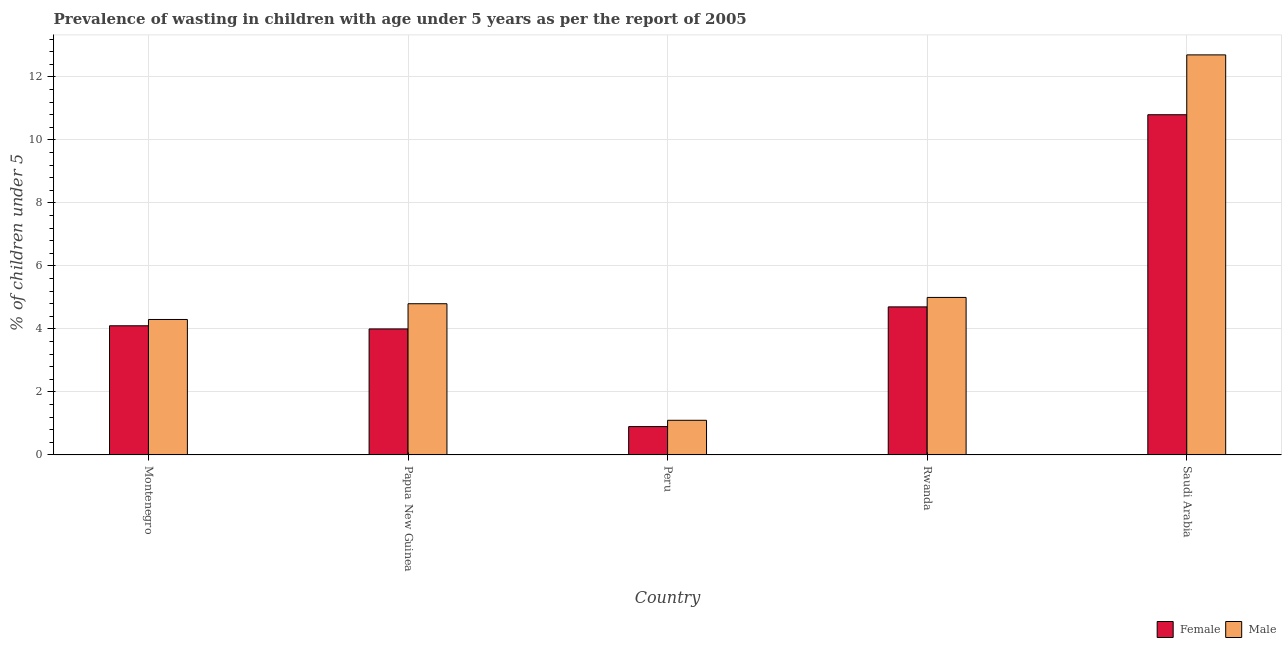How many different coloured bars are there?
Your answer should be compact. 2. How many groups of bars are there?
Make the answer very short. 5. What is the label of the 4th group of bars from the left?
Your answer should be compact. Rwanda. What is the percentage of undernourished female children in Montenegro?
Give a very brief answer. 4.1. Across all countries, what is the maximum percentage of undernourished male children?
Provide a succinct answer. 12.7. Across all countries, what is the minimum percentage of undernourished female children?
Provide a short and direct response. 0.9. In which country was the percentage of undernourished male children maximum?
Your answer should be compact. Saudi Arabia. What is the total percentage of undernourished male children in the graph?
Your answer should be very brief. 27.9. What is the difference between the percentage of undernourished male children in Rwanda and that in Saudi Arabia?
Keep it short and to the point. -7.7. What is the difference between the percentage of undernourished female children in Montenegro and the percentage of undernourished male children in Papua New Guinea?
Give a very brief answer. -0.7. What is the average percentage of undernourished female children per country?
Provide a short and direct response. 4.9. What is the difference between the percentage of undernourished female children and percentage of undernourished male children in Papua New Guinea?
Keep it short and to the point. -0.8. In how many countries, is the percentage of undernourished female children greater than 12.8 %?
Provide a succinct answer. 0. What is the ratio of the percentage of undernourished female children in Papua New Guinea to that in Peru?
Ensure brevity in your answer.  4.44. Is the difference between the percentage of undernourished male children in Montenegro and Saudi Arabia greater than the difference between the percentage of undernourished female children in Montenegro and Saudi Arabia?
Provide a short and direct response. No. What is the difference between the highest and the second highest percentage of undernourished female children?
Ensure brevity in your answer.  6.1. What is the difference between the highest and the lowest percentage of undernourished female children?
Ensure brevity in your answer.  9.9. Is the sum of the percentage of undernourished male children in Peru and Saudi Arabia greater than the maximum percentage of undernourished female children across all countries?
Ensure brevity in your answer.  Yes. What does the 2nd bar from the right in Rwanda represents?
Your answer should be compact. Female. Are all the bars in the graph horizontal?
Provide a succinct answer. No. How many countries are there in the graph?
Provide a short and direct response. 5. Does the graph contain any zero values?
Provide a succinct answer. No. Does the graph contain grids?
Give a very brief answer. Yes. Where does the legend appear in the graph?
Give a very brief answer. Bottom right. How many legend labels are there?
Your answer should be compact. 2. What is the title of the graph?
Your answer should be very brief. Prevalence of wasting in children with age under 5 years as per the report of 2005. Does "By country of asylum" appear as one of the legend labels in the graph?
Your response must be concise. No. What is the label or title of the Y-axis?
Make the answer very short.  % of children under 5. What is the  % of children under 5 in Female in Montenegro?
Keep it short and to the point. 4.1. What is the  % of children under 5 in Male in Montenegro?
Provide a succinct answer. 4.3. What is the  % of children under 5 in Male in Papua New Guinea?
Make the answer very short. 4.8. What is the  % of children under 5 of Female in Peru?
Offer a terse response. 0.9. What is the  % of children under 5 of Male in Peru?
Offer a very short reply. 1.1. What is the  % of children under 5 of Female in Rwanda?
Your response must be concise. 4.7. What is the  % of children under 5 of Female in Saudi Arabia?
Make the answer very short. 10.8. What is the  % of children under 5 of Male in Saudi Arabia?
Your answer should be compact. 12.7. Across all countries, what is the maximum  % of children under 5 in Female?
Offer a terse response. 10.8. Across all countries, what is the maximum  % of children under 5 in Male?
Your answer should be very brief. 12.7. Across all countries, what is the minimum  % of children under 5 of Female?
Your response must be concise. 0.9. Across all countries, what is the minimum  % of children under 5 in Male?
Keep it short and to the point. 1.1. What is the total  % of children under 5 in Male in the graph?
Offer a very short reply. 27.9. What is the difference between the  % of children under 5 in Male in Montenegro and that in Papua New Guinea?
Provide a short and direct response. -0.5. What is the difference between the  % of children under 5 of Male in Montenegro and that in Peru?
Ensure brevity in your answer.  3.2. What is the difference between the  % of children under 5 in Female in Montenegro and that in Rwanda?
Your response must be concise. -0.6. What is the difference between the  % of children under 5 in Male in Montenegro and that in Rwanda?
Offer a terse response. -0.7. What is the difference between the  % of children under 5 of Female in Montenegro and that in Saudi Arabia?
Offer a terse response. -6.7. What is the difference between the  % of children under 5 in Male in Montenegro and that in Saudi Arabia?
Your response must be concise. -8.4. What is the difference between the  % of children under 5 of Female in Papua New Guinea and that in Peru?
Provide a succinct answer. 3.1. What is the difference between the  % of children under 5 of Female in Papua New Guinea and that in Rwanda?
Ensure brevity in your answer.  -0.7. What is the difference between the  % of children under 5 of Male in Papua New Guinea and that in Rwanda?
Your response must be concise. -0.2. What is the difference between the  % of children under 5 of Female in Peru and that in Rwanda?
Offer a terse response. -3.8. What is the difference between the  % of children under 5 of Male in Peru and that in Rwanda?
Provide a short and direct response. -3.9. What is the difference between the  % of children under 5 in Male in Peru and that in Saudi Arabia?
Your response must be concise. -11.6. What is the difference between the  % of children under 5 of Female in Rwanda and that in Saudi Arabia?
Your answer should be compact. -6.1. What is the difference between the  % of children under 5 in Female in Montenegro and the  % of children under 5 in Male in Papua New Guinea?
Provide a succinct answer. -0.7. What is the difference between the  % of children under 5 in Female in Montenegro and the  % of children under 5 in Male in Saudi Arabia?
Provide a short and direct response. -8.6. What is the difference between the  % of children under 5 in Female in Papua New Guinea and the  % of children under 5 in Male in Rwanda?
Your answer should be very brief. -1. What is the difference between the  % of children under 5 in Female in Papua New Guinea and the  % of children under 5 in Male in Saudi Arabia?
Your response must be concise. -8.7. What is the difference between the  % of children under 5 of Female in Peru and the  % of children under 5 of Male in Saudi Arabia?
Keep it short and to the point. -11.8. What is the average  % of children under 5 of Female per country?
Give a very brief answer. 4.9. What is the average  % of children under 5 of Male per country?
Ensure brevity in your answer.  5.58. What is the difference between the  % of children under 5 in Female and  % of children under 5 in Male in Montenegro?
Offer a terse response. -0.2. What is the difference between the  % of children under 5 of Female and  % of children under 5 of Male in Rwanda?
Give a very brief answer. -0.3. What is the ratio of the  % of children under 5 in Male in Montenegro to that in Papua New Guinea?
Make the answer very short. 0.9. What is the ratio of the  % of children under 5 of Female in Montenegro to that in Peru?
Give a very brief answer. 4.56. What is the ratio of the  % of children under 5 of Male in Montenegro to that in Peru?
Make the answer very short. 3.91. What is the ratio of the  % of children under 5 of Female in Montenegro to that in Rwanda?
Make the answer very short. 0.87. What is the ratio of the  % of children under 5 of Male in Montenegro to that in Rwanda?
Your answer should be compact. 0.86. What is the ratio of the  % of children under 5 in Female in Montenegro to that in Saudi Arabia?
Make the answer very short. 0.38. What is the ratio of the  % of children under 5 of Male in Montenegro to that in Saudi Arabia?
Provide a short and direct response. 0.34. What is the ratio of the  % of children under 5 in Female in Papua New Guinea to that in Peru?
Ensure brevity in your answer.  4.44. What is the ratio of the  % of children under 5 in Male in Papua New Guinea to that in Peru?
Make the answer very short. 4.36. What is the ratio of the  % of children under 5 of Female in Papua New Guinea to that in Rwanda?
Your answer should be very brief. 0.85. What is the ratio of the  % of children under 5 of Female in Papua New Guinea to that in Saudi Arabia?
Make the answer very short. 0.37. What is the ratio of the  % of children under 5 of Male in Papua New Guinea to that in Saudi Arabia?
Provide a short and direct response. 0.38. What is the ratio of the  % of children under 5 in Female in Peru to that in Rwanda?
Your answer should be very brief. 0.19. What is the ratio of the  % of children under 5 in Male in Peru to that in Rwanda?
Offer a very short reply. 0.22. What is the ratio of the  % of children under 5 in Female in Peru to that in Saudi Arabia?
Offer a very short reply. 0.08. What is the ratio of the  % of children under 5 of Male in Peru to that in Saudi Arabia?
Ensure brevity in your answer.  0.09. What is the ratio of the  % of children under 5 of Female in Rwanda to that in Saudi Arabia?
Provide a succinct answer. 0.44. What is the ratio of the  % of children under 5 of Male in Rwanda to that in Saudi Arabia?
Make the answer very short. 0.39. What is the difference between the highest and the second highest  % of children under 5 in Female?
Keep it short and to the point. 6.1. What is the difference between the highest and the second highest  % of children under 5 in Male?
Keep it short and to the point. 7.7. 